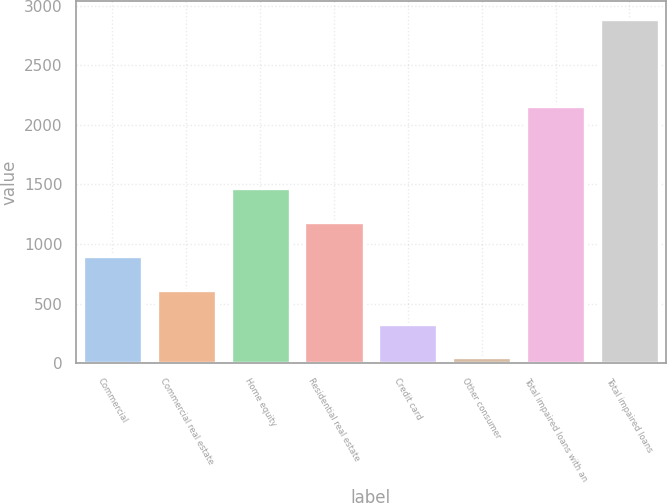<chart> <loc_0><loc_0><loc_500><loc_500><bar_chart><fcel>Commercial<fcel>Commercial real estate<fcel>Home equity<fcel>Residential real estate<fcel>Credit card<fcel>Other consumer<fcel>Total impaired loans with an<fcel>Total impaired loans<nl><fcel>900.5<fcel>616<fcel>1469.5<fcel>1185<fcel>331.5<fcel>47<fcel>2161<fcel>2892<nl></chart> 